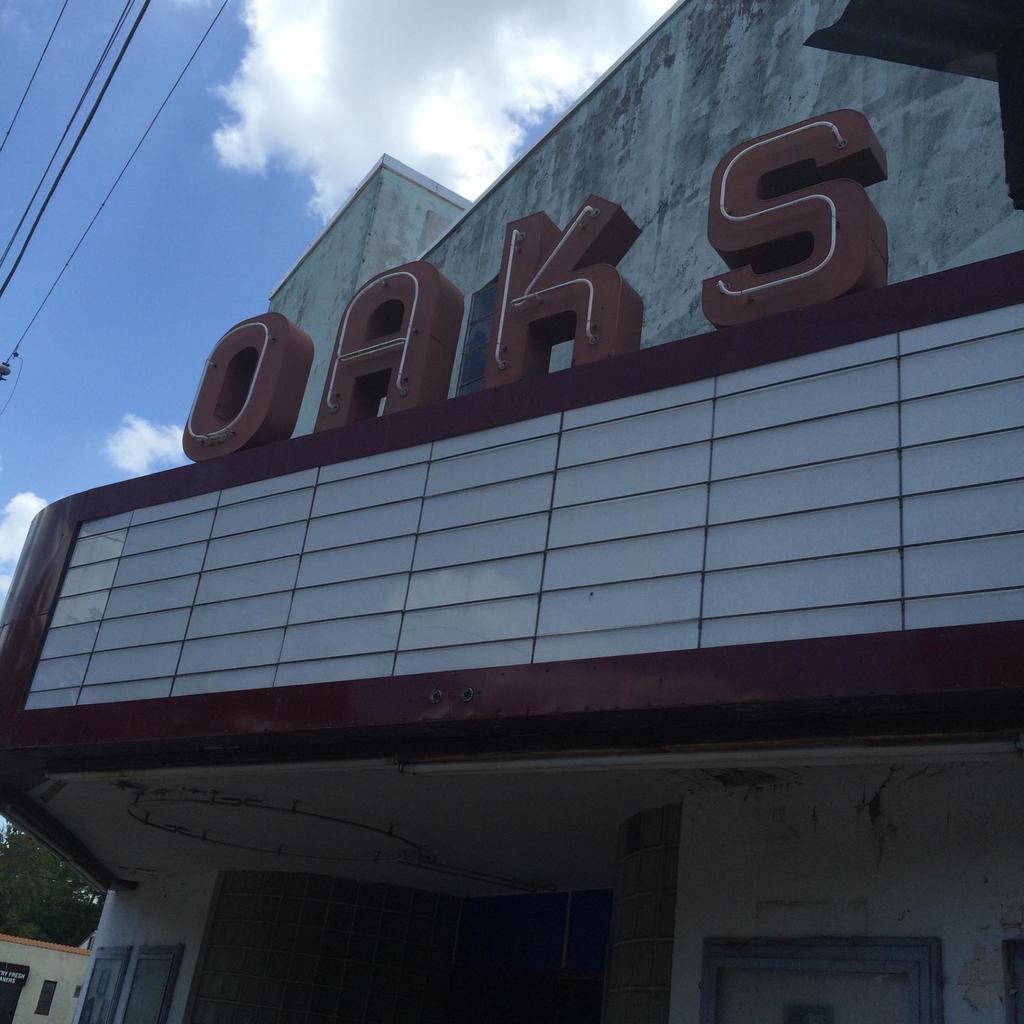Could you give a brief overview of what you see in this image? In this image we can see houses, there are text on the wall, also we can see wires, trees, and the sky. 